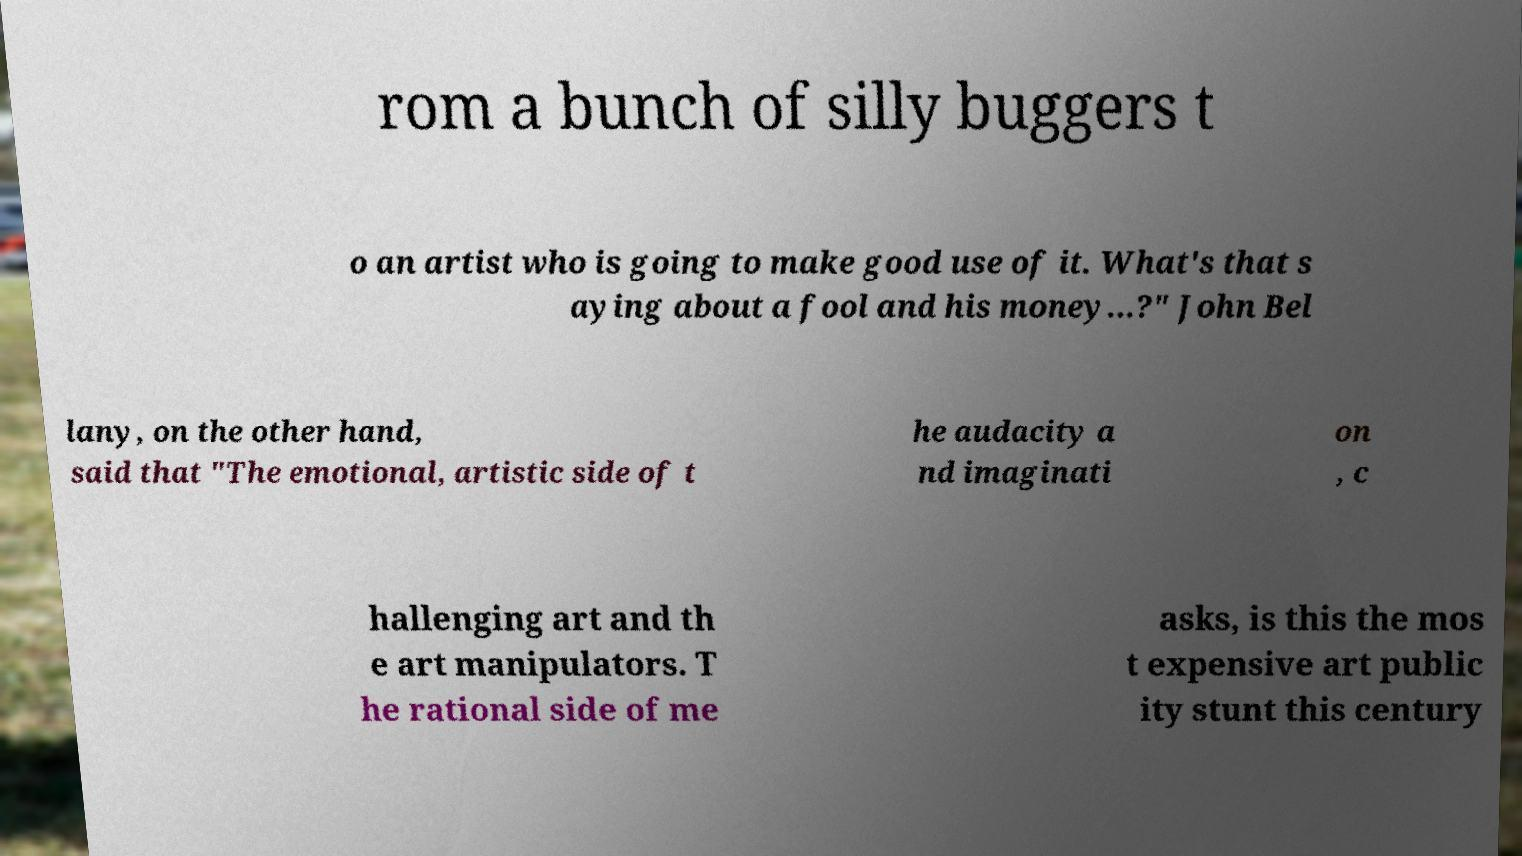Can you read and provide the text displayed in the image?This photo seems to have some interesting text. Can you extract and type it out for me? rom a bunch of silly buggers t o an artist who is going to make good use of it. What's that s aying about a fool and his money...?" John Bel lany, on the other hand, said that "The emotional, artistic side of t he audacity a nd imaginati on , c hallenging art and th e art manipulators. T he rational side of me asks, is this the mos t expensive art public ity stunt this century 